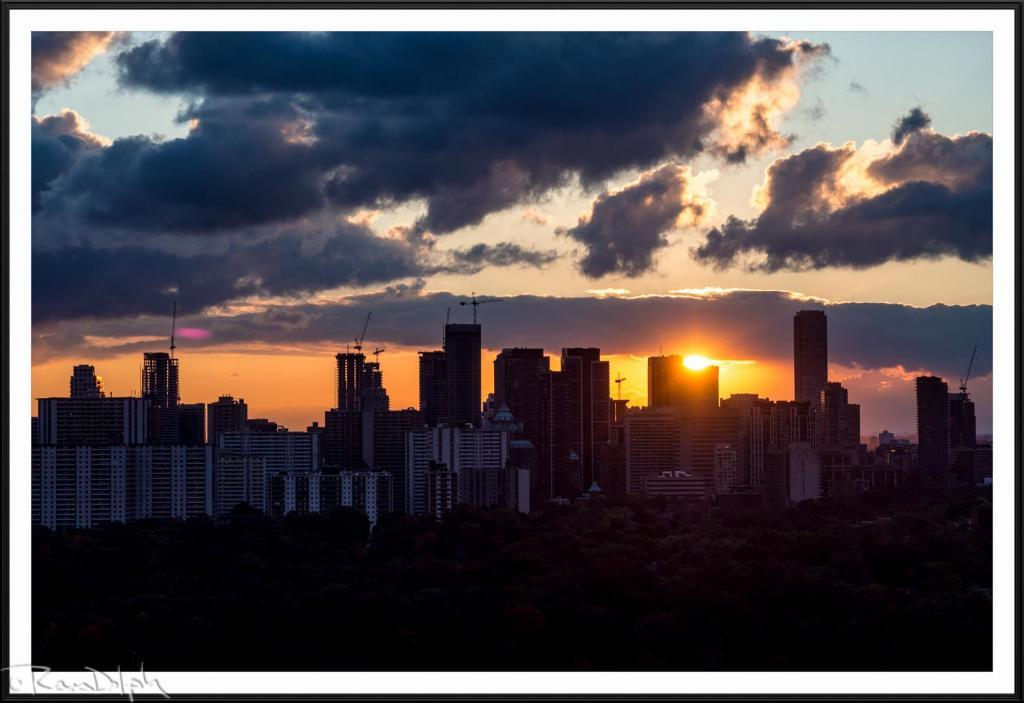What structures are located in the front of the image? There are buildings in the front of the image. What can be seen in the background of the image? Clouds, the sky, and the sun are visible in the background of the image. Can you see any kites flying in the image? There is no kite present in the image. What type of sand can be seen on the beach in the image? There is no beach or sand present in the image; it features buildings and a sky with clouds and the sun. 